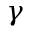<formula> <loc_0><loc_0><loc_500><loc_500>\gamma</formula> 